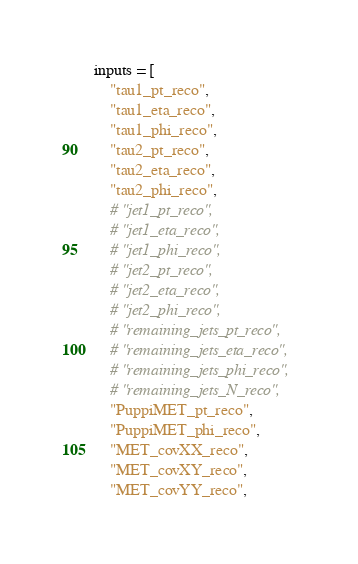Convert code to text. <code><loc_0><loc_0><loc_500><loc_500><_Python_>inputs = [
    "tau1_pt_reco",
    "tau1_eta_reco",
    "tau1_phi_reco",
    "tau2_pt_reco",
    "tau2_eta_reco",
    "tau2_phi_reco",
    # "jet1_pt_reco",
    # "jet1_eta_reco",
    # "jet1_phi_reco",
    # "jet2_pt_reco",
    # "jet2_eta_reco",
    # "jet2_phi_reco",
    # "remaining_jets_pt_reco",
    # "remaining_jets_eta_reco",
    # "remaining_jets_phi_reco",
    # "remaining_jets_N_reco",
    "PuppiMET_pt_reco",
    "PuppiMET_phi_reco",
    "MET_covXX_reco",
    "MET_covXY_reco",
    "MET_covYY_reco",</code> 